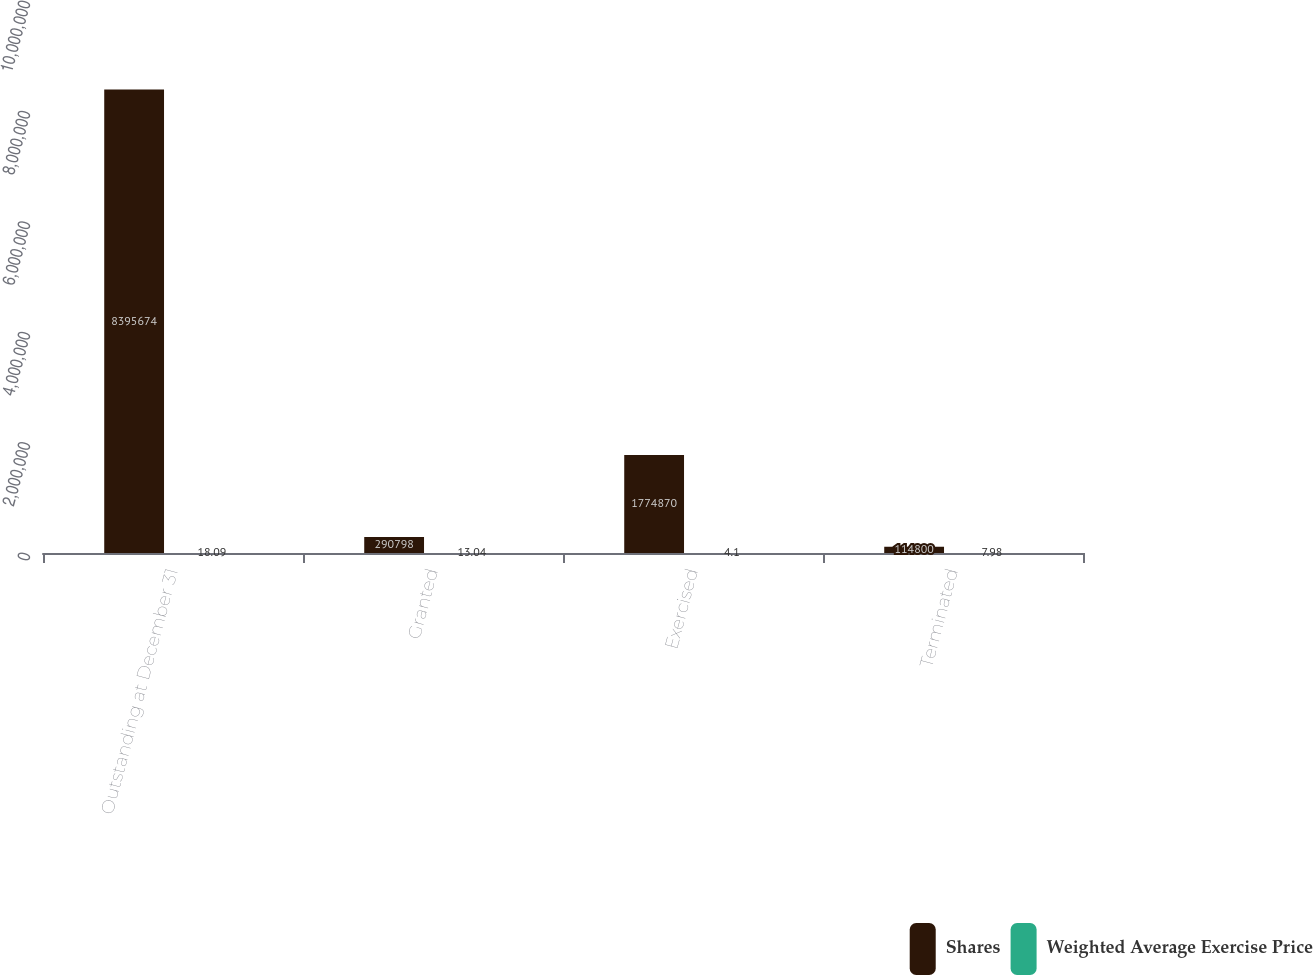Convert chart to OTSL. <chart><loc_0><loc_0><loc_500><loc_500><stacked_bar_chart><ecel><fcel>Outstanding at December 31<fcel>Granted<fcel>Exercised<fcel>Terminated<nl><fcel>Shares<fcel>8.39567e+06<fcel>290798<fcel>1.77487e+06<fcel>114800<nl><fcel>Weighted Average Exercise Price<fcel>18.09<fcel>13.04<fcel>4.1<fcel>7.98<nl></chart> 